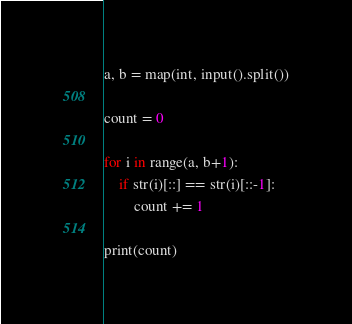<code> <loc_0><loc_0><loc_500><loc_500><_Python_>a, b = map(int, input().split())

count = 0

for i in range(a, b+1):
    if str(i)[::] == str(i)[::-1]:
        count += 1

print(count)</code> 